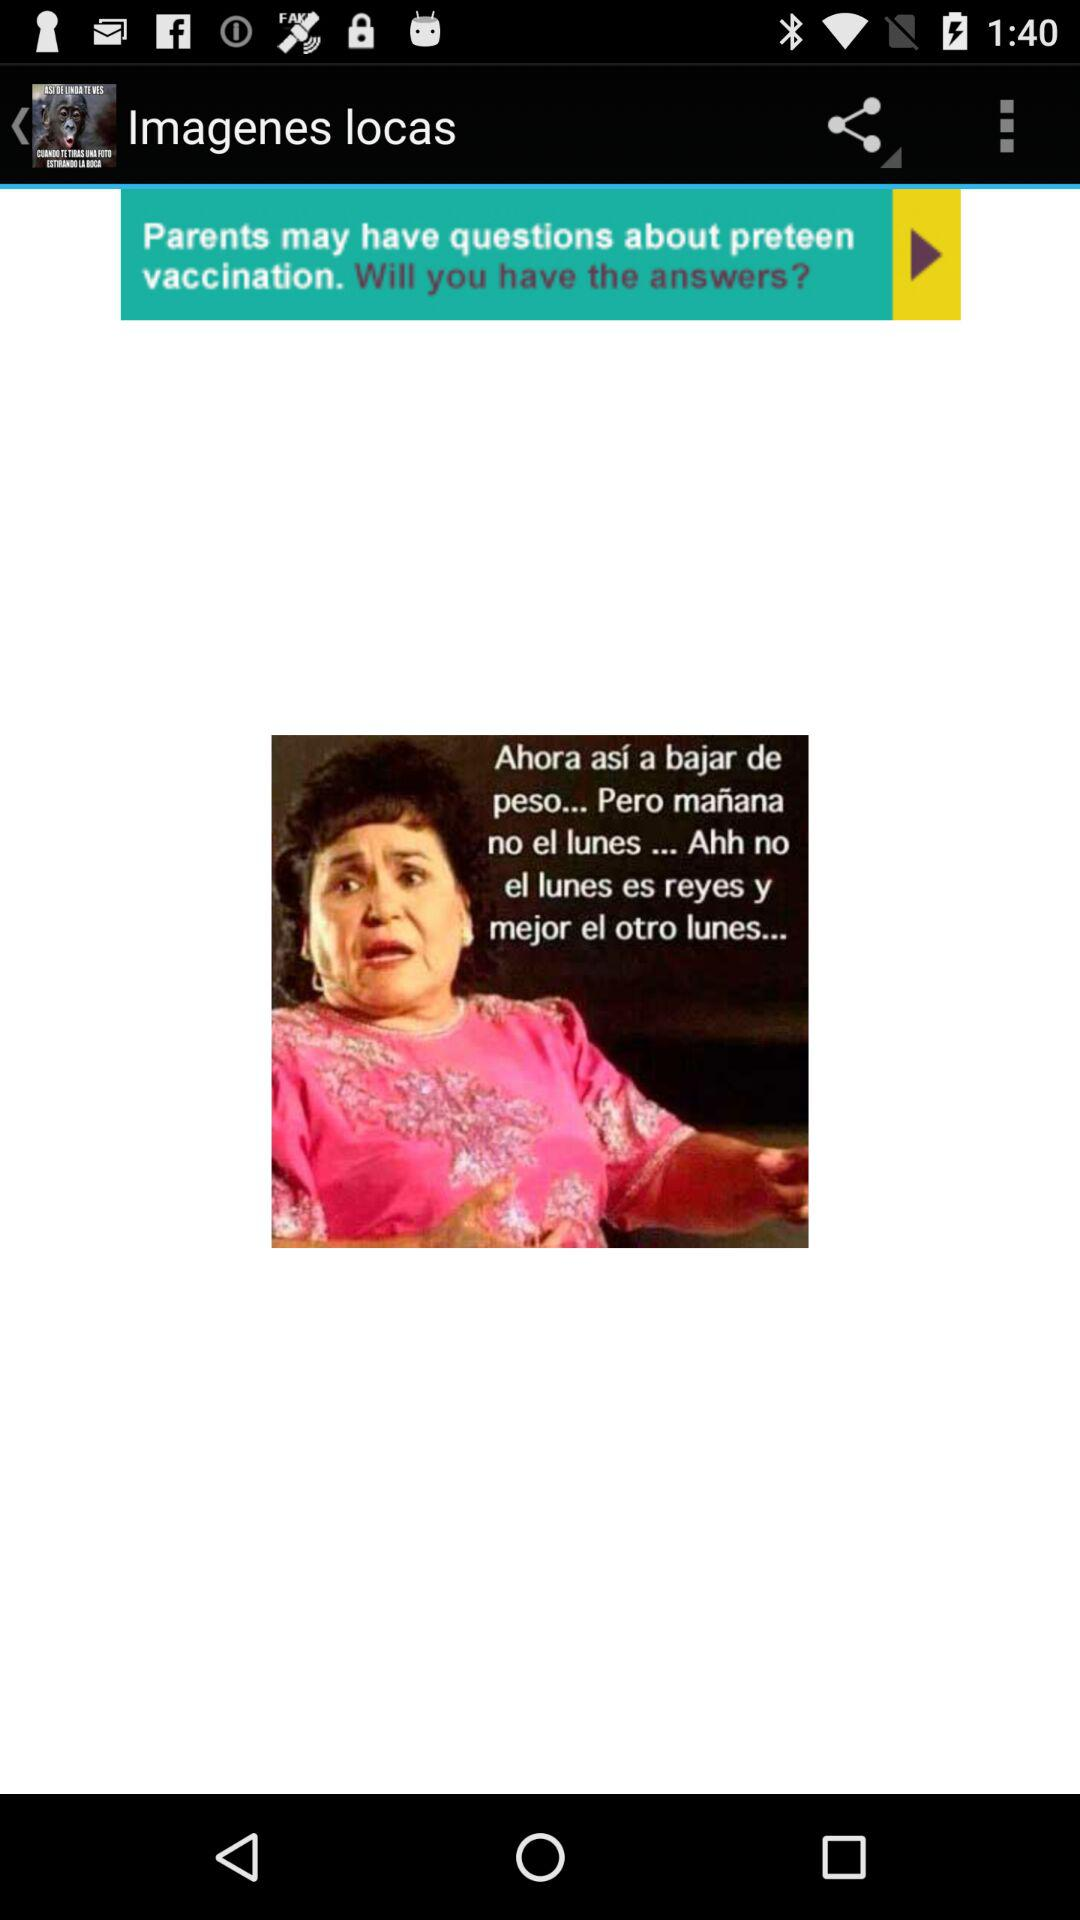What is the application name? The application name is "Imagenes locas". 